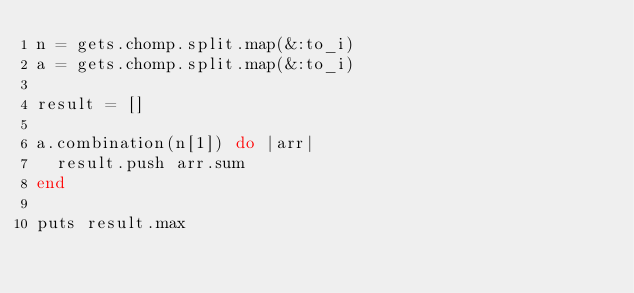<code> <loc_0><loc_0><loc_500><loc_500><_Ruby_>n = gets.chomp.split.map(&:to_i)
a = gets.chomp.split.map(&:to_i)

result = []

a.combination(n[1]) do |arr|
  result.push arr.sum
end

puts result.max</code> 